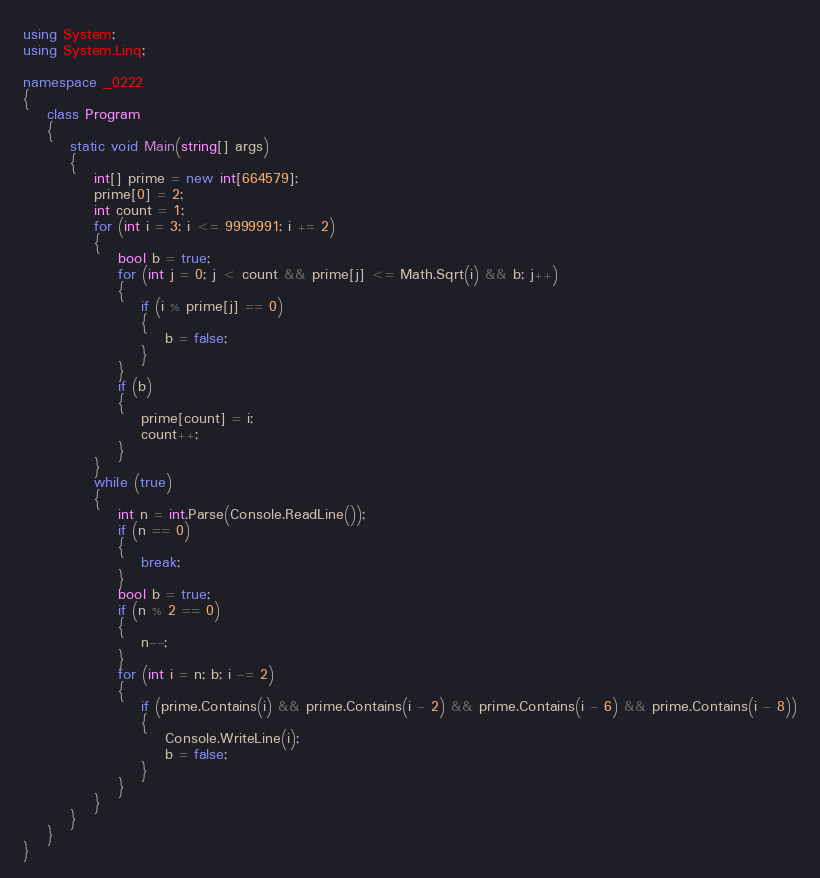<code> <loc_0><loc_0><loc_500><loc_500><_C#_>using System;
using System.Linq;

namespace _0222
{
    class Program
    {
        static void Main(string[] args)
        {
            int[] prime = new int[664579];
            prime[0] = 2;
            int count = 1;
            for (int i = 3; i <= 9999991; i += 2)
            {
                bool b = true;
                for (int j = 0; j < count && prime[j] <= Math.Sqrt(i) && b; j++)
                {
                    if (i % prime[j] == 0)
                    {
                        b = false;
                    }
                }
                if (b)
                {
                    prime[count] = i;
                    count++;
                }
            }
            while (true)
            {
                int n = int.Parse(Console.ReadLine());
                if (n == 0)
                {
                    break;
                }
                bool b = true;
                if (n % 2 == 0)
                {
                    n--;
                }
                for (int i = n; b; i -= 2)
                {
                    if (prime.Contains(i) && prime.Contains(i - 2) && prime.Contains(i - 6) && prime.Contains(i - 8))
                    {
                        Console.WriteLine(i);
                        b = false;
                    }
                }
            }
        }
    }
}</code> 